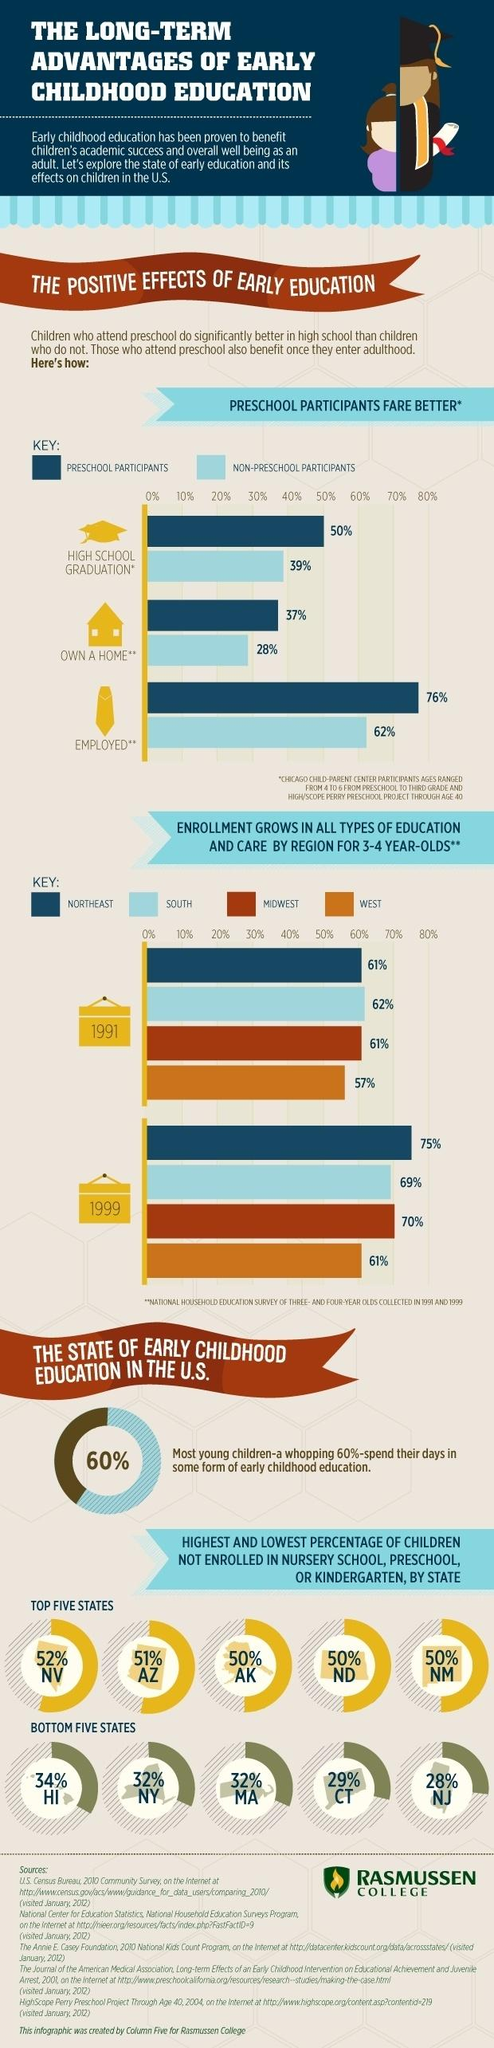Indicate a few pertinent items in this graphic. The difference in high school graduation rates between preschool participants and non-preschool participants is 11%. The study found that there is a significant difference between preschool participants and non-preschool participants who own a home, with preschool participants having a higher rate of home ownership at 9%. According to recent data, several states, including Alaska, North Dakota, and New Mexico, have a significant proportion of children not enrolled in nursery school, preschool, or kindergarten. According to data, 32% of children in states such as New York and Massachusetts have not enrolled in nursery school, preschool, or kindergarten. The survey found that preschool participants and non-preschool participants who are employed have a statistically significant difference of 14% in the likelihood of being in the top wealth quintile. 